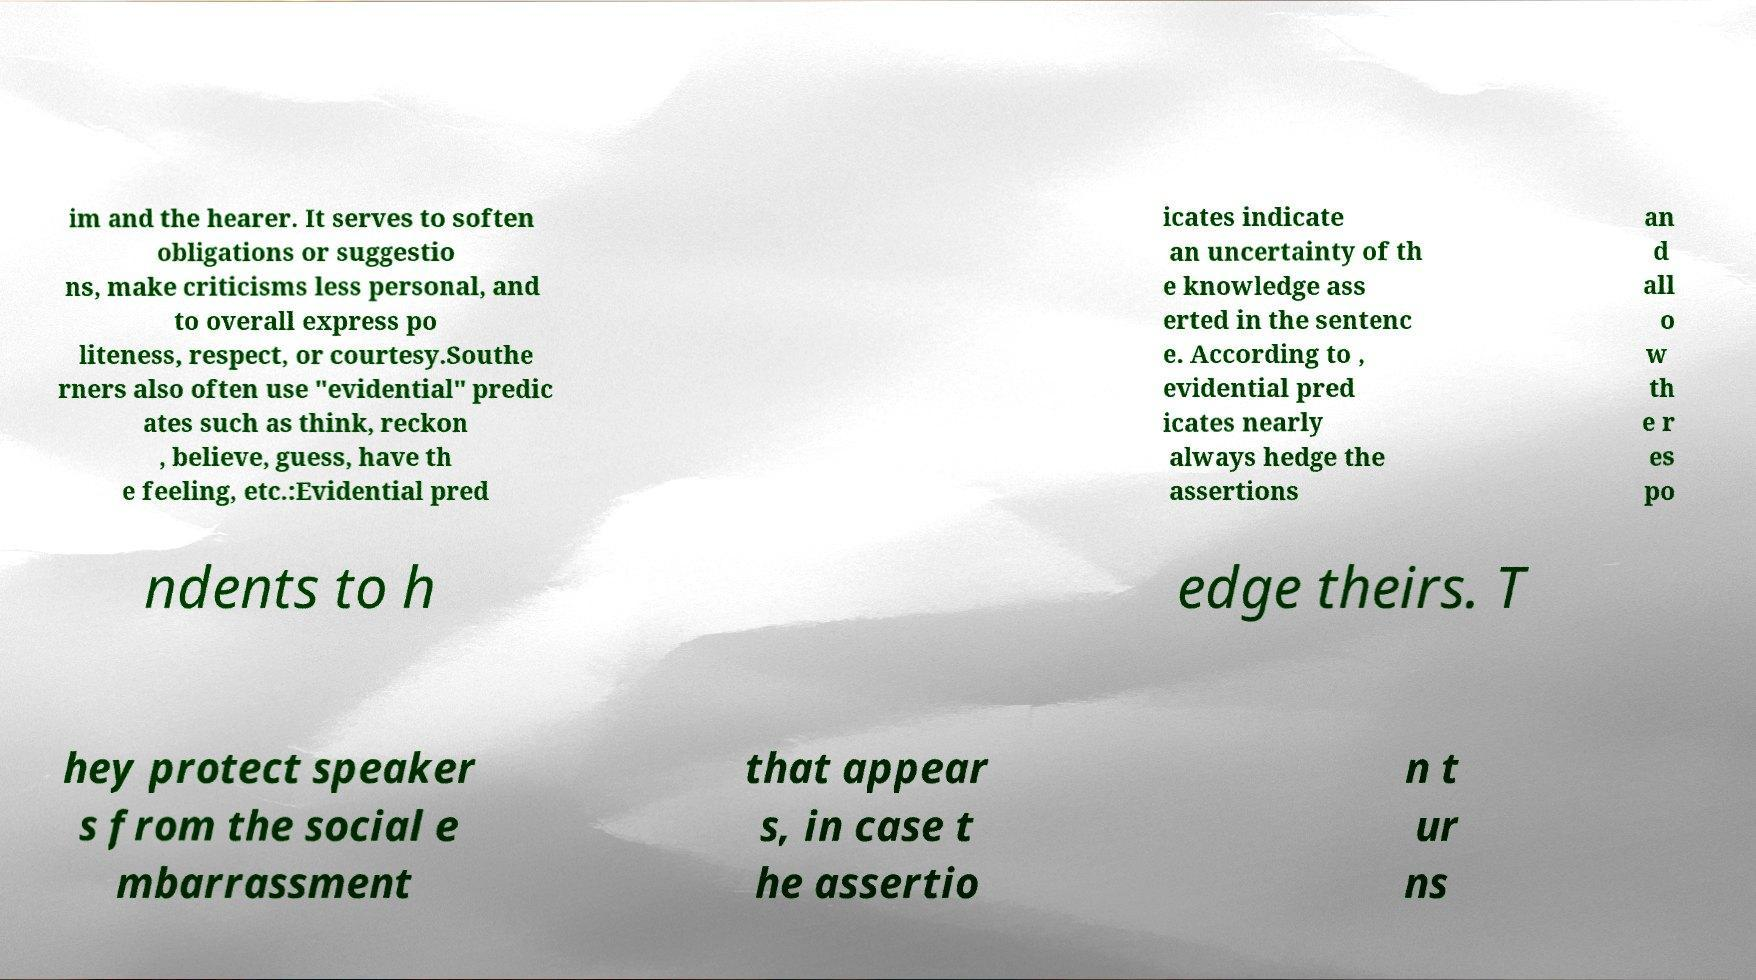I need the written content from this picture converted into text. Can you do that? im and the hearer. It serves to soften obligations or suggestio ns, make criticisms less personal, and to overall express po liteness, respect, or courtesy.Southe rners also often use "evidential" predic ates such as think, reckon , believe, guess, have th e feeling, etc.:Evidential pred icates indicate an uncertainty of th e knowledge ass erted in the sentenc e. According to , evidential pred icates nearly always hedge the assertions an d all o w th e r es po ndents to h edge theirs. T hey protect speaker s from the social e mbarrassment that appear s, in case t he assertio n t ur ns 